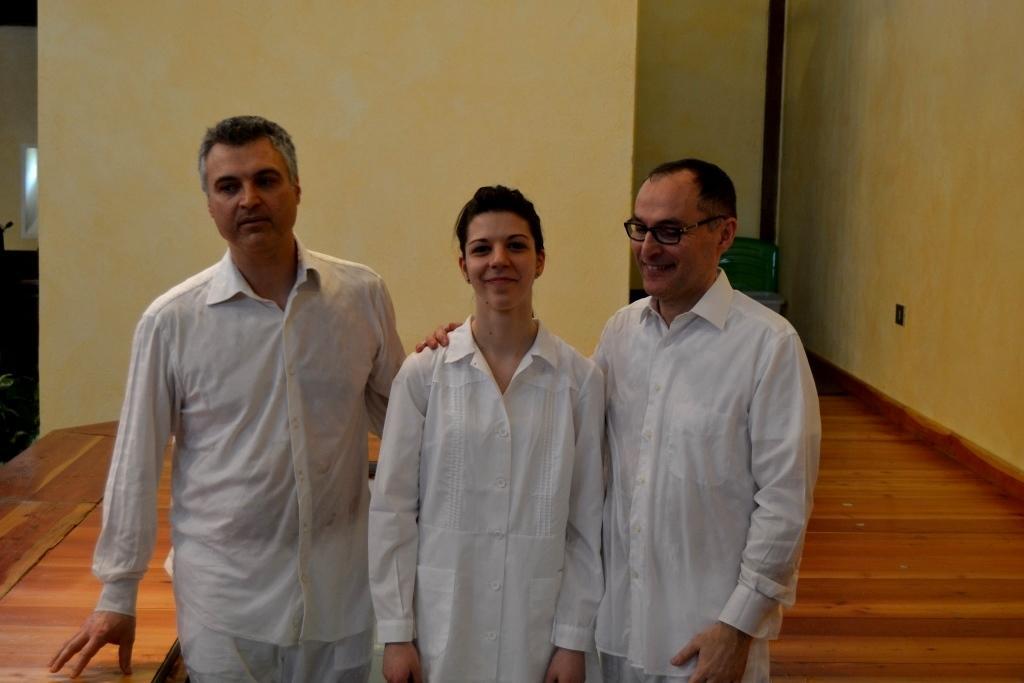Please provide a concise description of this image. In this picture I can see there are two men and one woman, they are wearing white shirts and there is a wooden floor. 